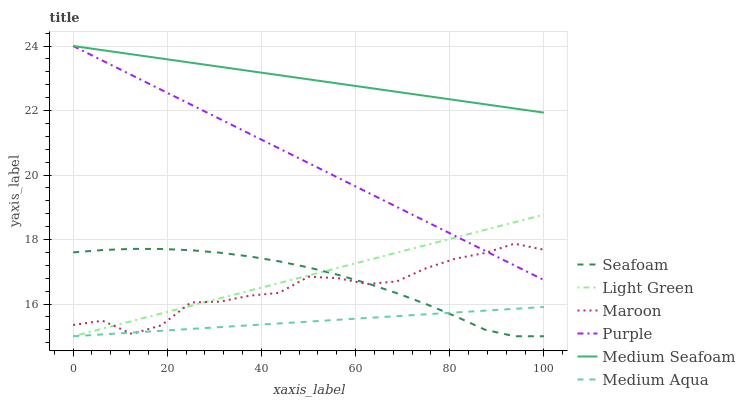Does Medium Aqua have the minimum area under the curve?
Answer yes or no. Yes. Does Medium Seafoam have the maximum area under the curve?
Answer yes or no. Yes. Does Seafoam have the minimum area under the curve?
Answer yes or no. No. Does Seafoam have the maximum area under the curve?
Answer yes or no. No. Is Medium Seafoam the smoothest?
Answer yes or no. Yes. Is Maroon the roughest?
Answer yes or no. Yes. Is Seafoam the smoothest?
Answer yes or no. No. Is Seafoam the roughest?
Answer yes or no. No. Does Maroon have the lowest value?
Answer yes or no. No. Does Seafoam have the highest value?
Answer yes or no. No. Is Medium Aqua less than Purple?
Answer yes or no. Yes. Is Purple greater than Seafoam?
Answer yes or no. Yes. Does Medium Aqua intersect Purple?
Answer yes or no. No. 